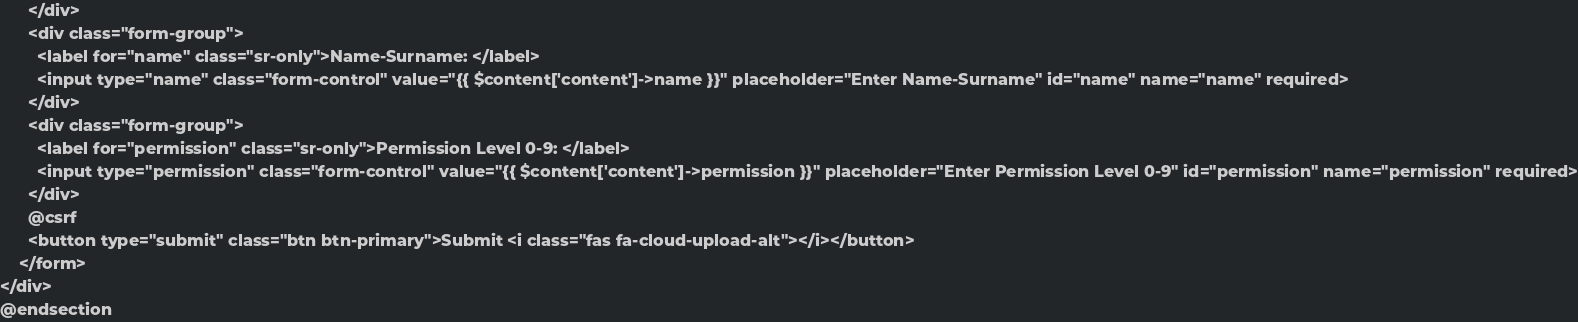Convert code to text. <code><loc_0><loc_0><loc_500><loc_500><_PHP_>      </div>
      <div class="form-group">
        <label for="name" class="sr-only">Name-Surname: </label>
        <input type="name" class="form-control" value="{{ $content['content']->name }}" placeholder="Enter Name-Surname" id="name" name="name" required>
      </div>
      <div class="form-group">
        <label for="permission" class="sr-only">Permission Level 0-9: </label>
        <input type="permission" class="form-control" value="{{ $content['content']->permission }}" placeholder="Enter Permission Level 0-9" id="permission" name="permission" required>
      </div>
      @csrf
      <button type="submit" class="btn btn-primary">Submit <i class="fas fa-cloud-upload-alt"></i></button>
    </form>
</div>
@endsection
</code> 